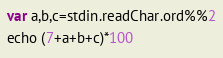Convert code to text. <code><loc_0><loc_0><loc_500><loc_500><_Nim_>var a,b,c=stdin.readChar.ord%%2
echo (7+a+b+c)*100</code> 